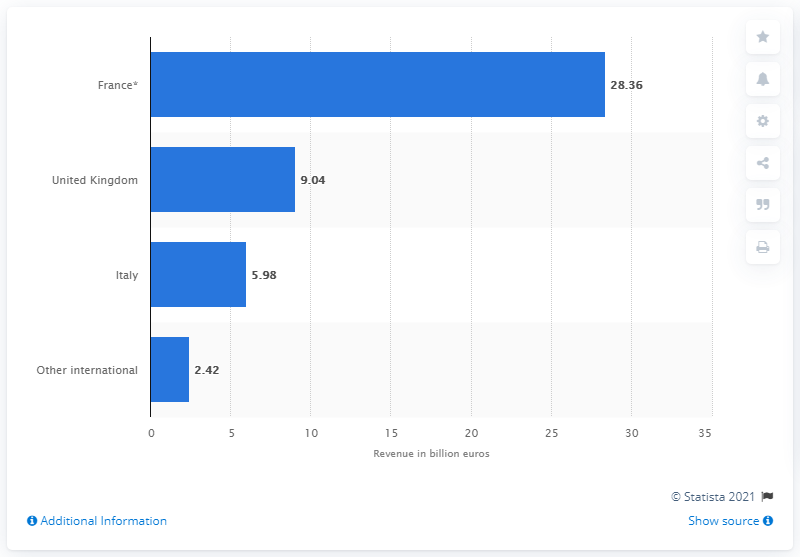Draw attention to some important aspects in this diagram. EDF generated 28.36 billion euros in its home market in the past. In the United Kingdom, EDF generated 28.36 million in revenue. 